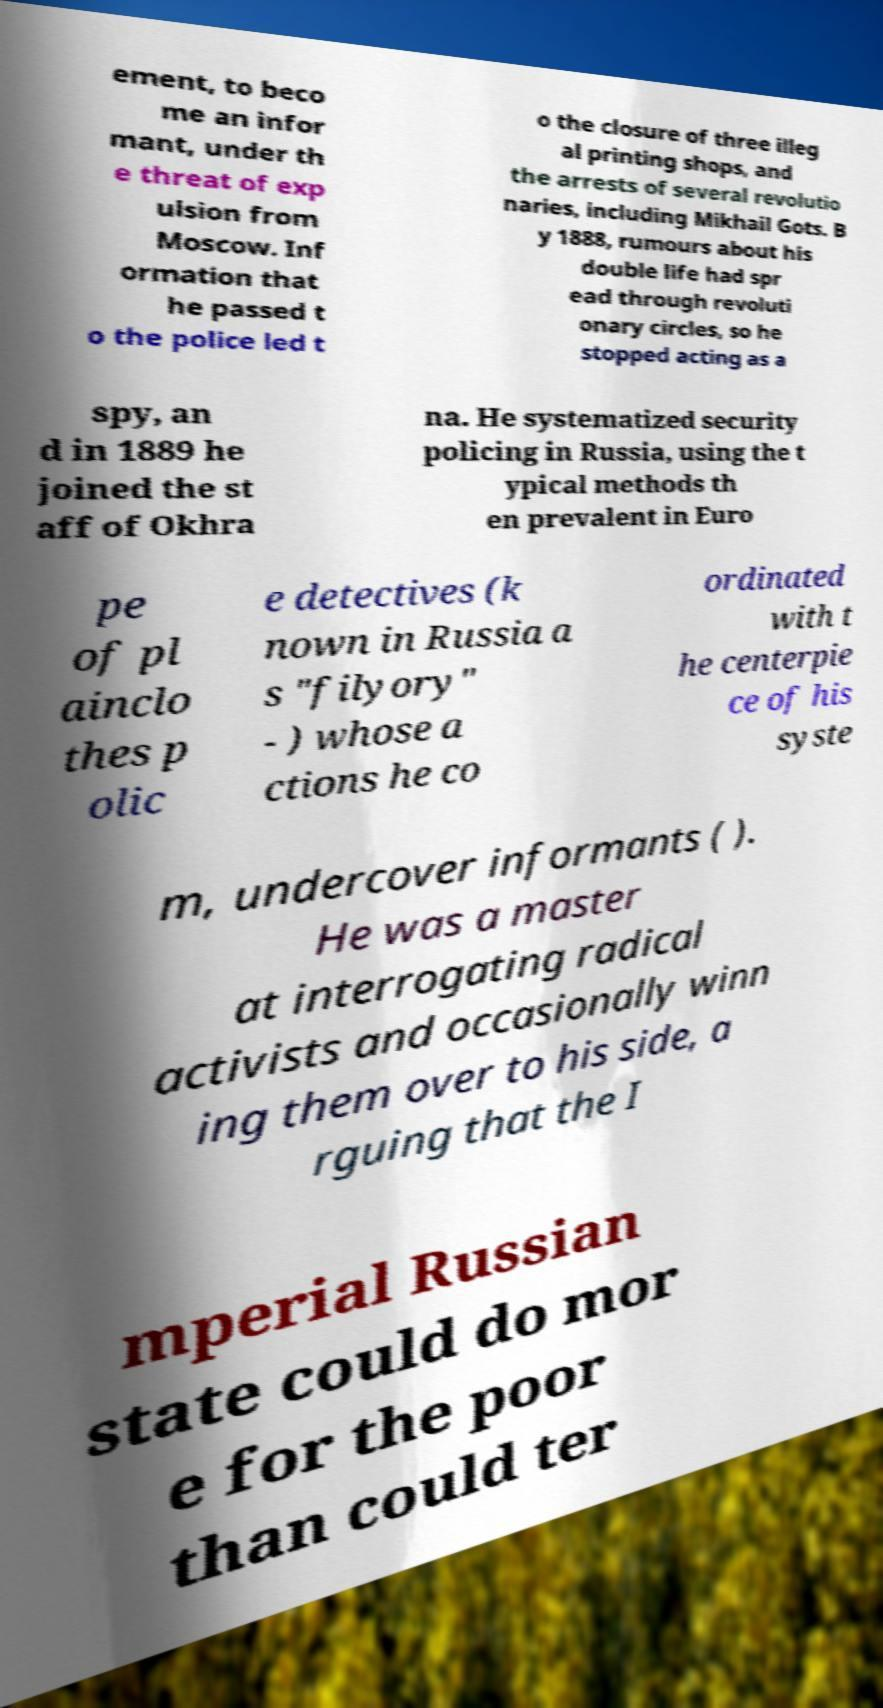Can you accurately transcribe the text from the provided image for me? ement, to beco me an infor mant, under th e threat of exp ulsion from Moscow. Inf ormation that he passed t o the police led t o the closure of three illeg al printing shops, and the arrests of several revolutio naries, including Mikhail Gots. B y 1888, rumours about his double life had spr ead through revoluti onary circles, so he stopped acting as a spy, an d in 1889 he joined the st aff of Okhra na. He systematized security policing in Russia, using the t ypical methods th en prevalent in Euro pe of pl ainclo thes p olic e detectives (k nown in Russia a s "filyory" - ) whose a ctions he co ordinated with t he centerpie ce of his syste m, undercover informants ( ). He was a master at interrogating radical activists and occasionally winn ing them over to his side, a rguing that the I mperial Russian state could do mor e for the poor than could ter 